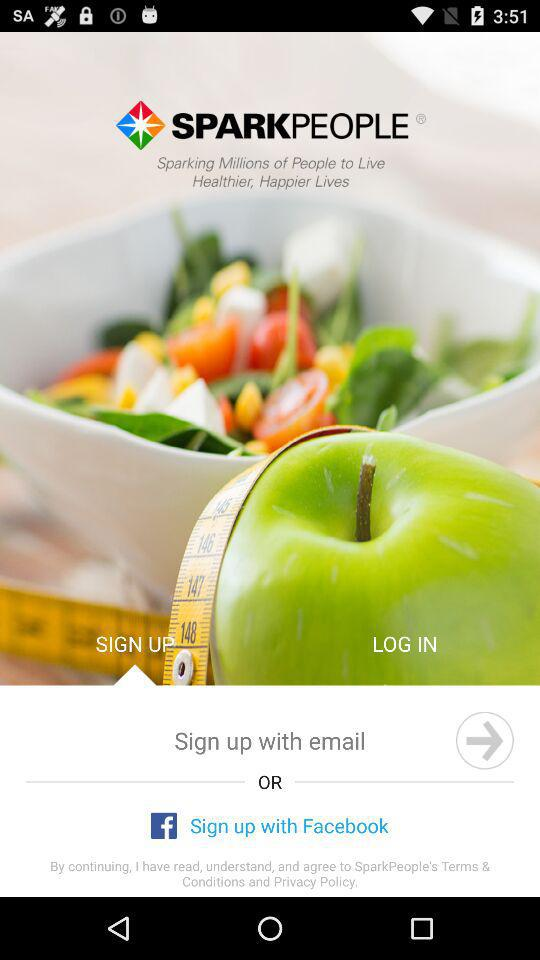Which account can be used to sign up? The accounts that can be used to sign up are "email" and "Facebook". 